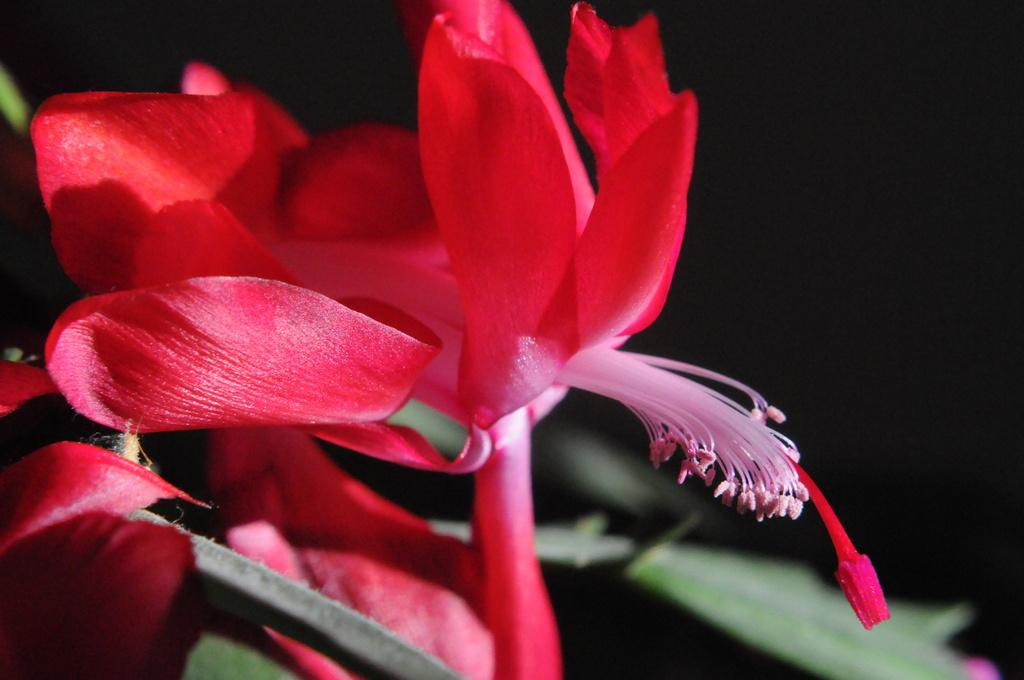What is present in the image? There is a flower in the image. Can you describe the flower in the image? The flower is red in color. How many fangs can be seen on the flower in the image? There are no fangs present on the flower in the image, as flowers do not have fangs. 